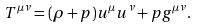Convert formula to latex. <formula><loc_0><loc_0><loc_500><loc_500>T ^ { \mu \nu } = ( \rho + p ) u ^ { \mu } u ^ { \nu } + p g ^ { \mu \nu } .</formula> 